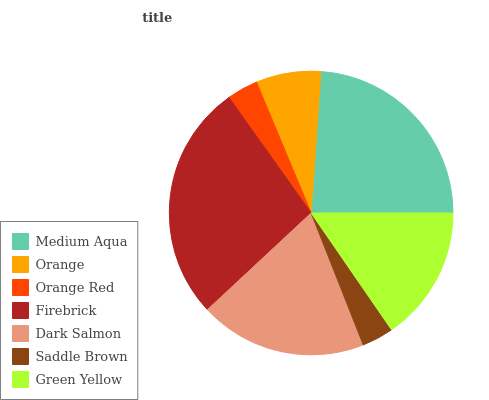Is Orange Red the minimum?
Answer yes or no. Yes. Is Firebrick the maximum?
Answer yes or no. Yes. Is Orange the minimum?
Answer yes or no. No. Is Orange the maximum?
Answer yes or no. No. Is Medium Aqua greater than Orange?
Answer yes or no. Yes. Is Orange less than Medium Aqua?
Answer yes or no. Yes. Is Orange greater than Medium Aqua?
Answer yes or no. No. Is Medium Aqua less than Orange?
Answer yes or no. No. Is Green Yellow the high median?
Answer yes or no. Yes. Is Green Yellow the low median?
Answer yes or no. Yes. Is Dark Salmon the high median?
Answer yes or no. No. Is Medium Aqua the low median?
Answer yes or no. No. 